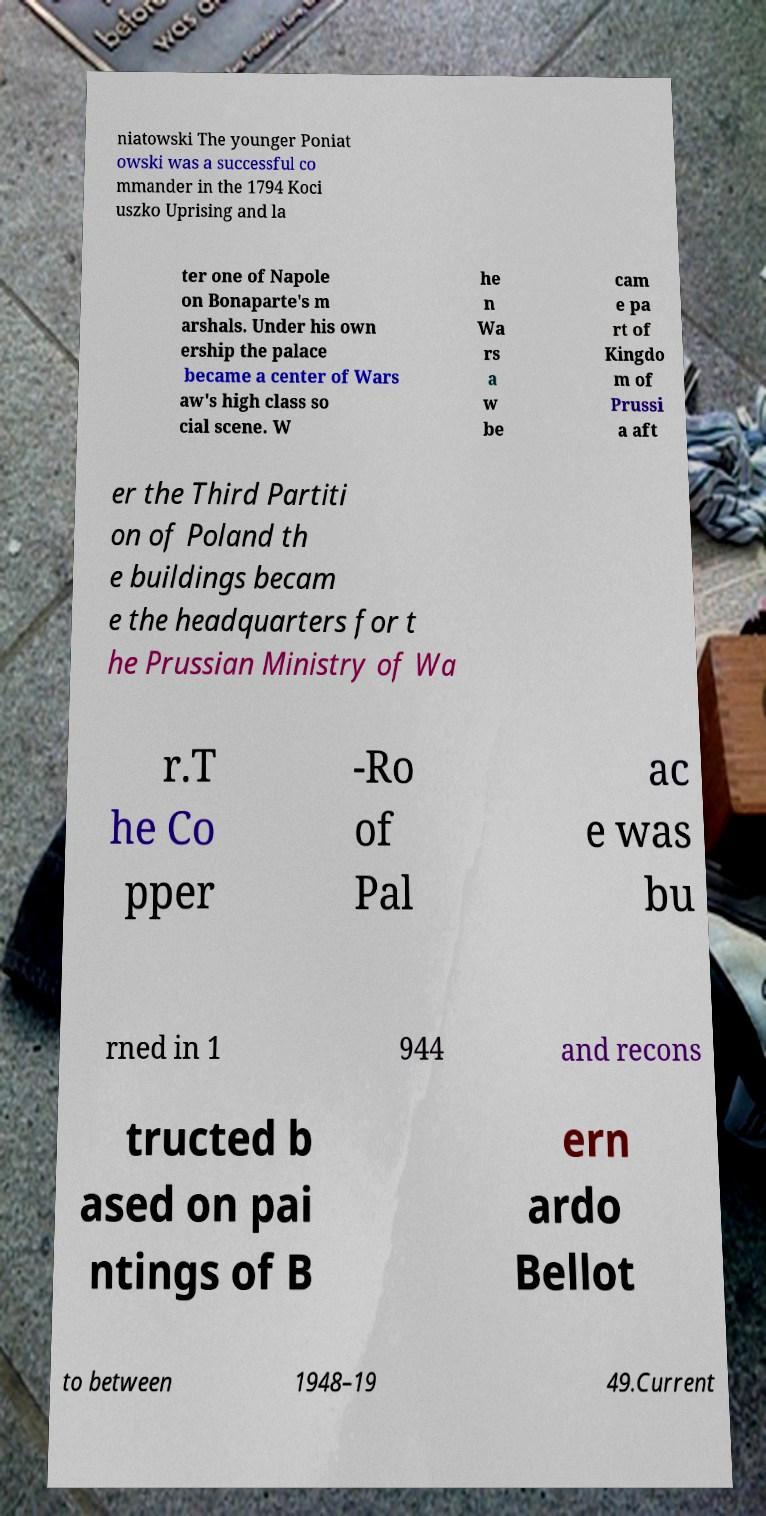Please read and relay the text visible in this image. What does it say? niatowski The younger Poniat owski was a successful co mmander in the 1794 Koci uszko Uprising and la ter one of Napole on Bonaparte's m arshals. Under his own ership the palace became a center of Wars aw's high class so cial scene. W he n Wa rs a w be cam e pa rt of Kingdo m of Prussi a aft er the Third Partiti on of Poland th e buildings becam e the headquarters for t he Prussian Ministry of Wa r.T he Co pper -Ro of Pal ac e was bu rned in 1 944 and recons tructed b ased on pai ntings of B ern ardo Bellot to between 1948–19 49.Current 